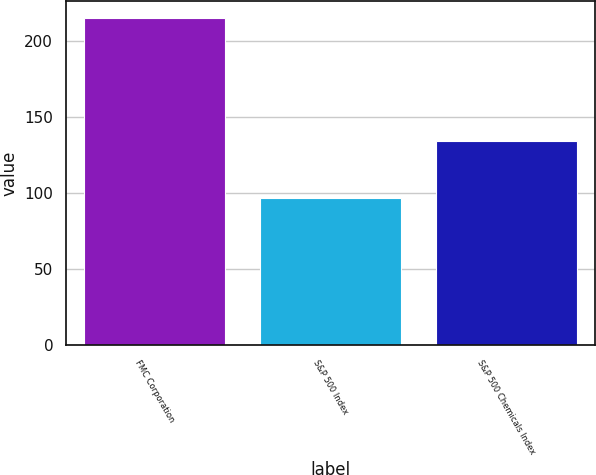Convert chart to OTSL. <chart><loc_0><loc_0><loc_500><loc_500><bar_chart><fcel>FMC Corporation<fcel>S&P 500 Index<fcel>S&P 500 Chemicals Index<nl><fcel>215.78<fcel>96.82<fcel>134.15<nl></chart> 